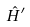<formula> <loc_0><loc_0><loc_500><loc_500>\hat { H } ^ { \prime }</formula> 